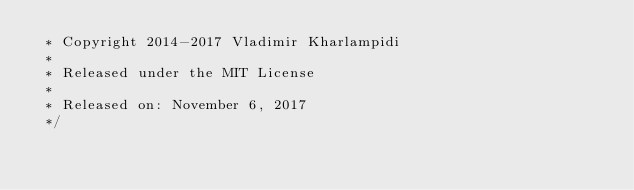<code> <loc_0><loc_0><loc_500><loc_500><_CSS_> * Copyright 2014-2017 Vladimir Kharlampidi
 *
 * Released under the MIT License
 *
 * Released on: November 6, 2017
 */</code> 